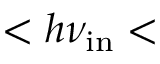<formula> <loc_0><loc_0><loc_500><loc_500>< h \nu _ { i n } <</formula> 